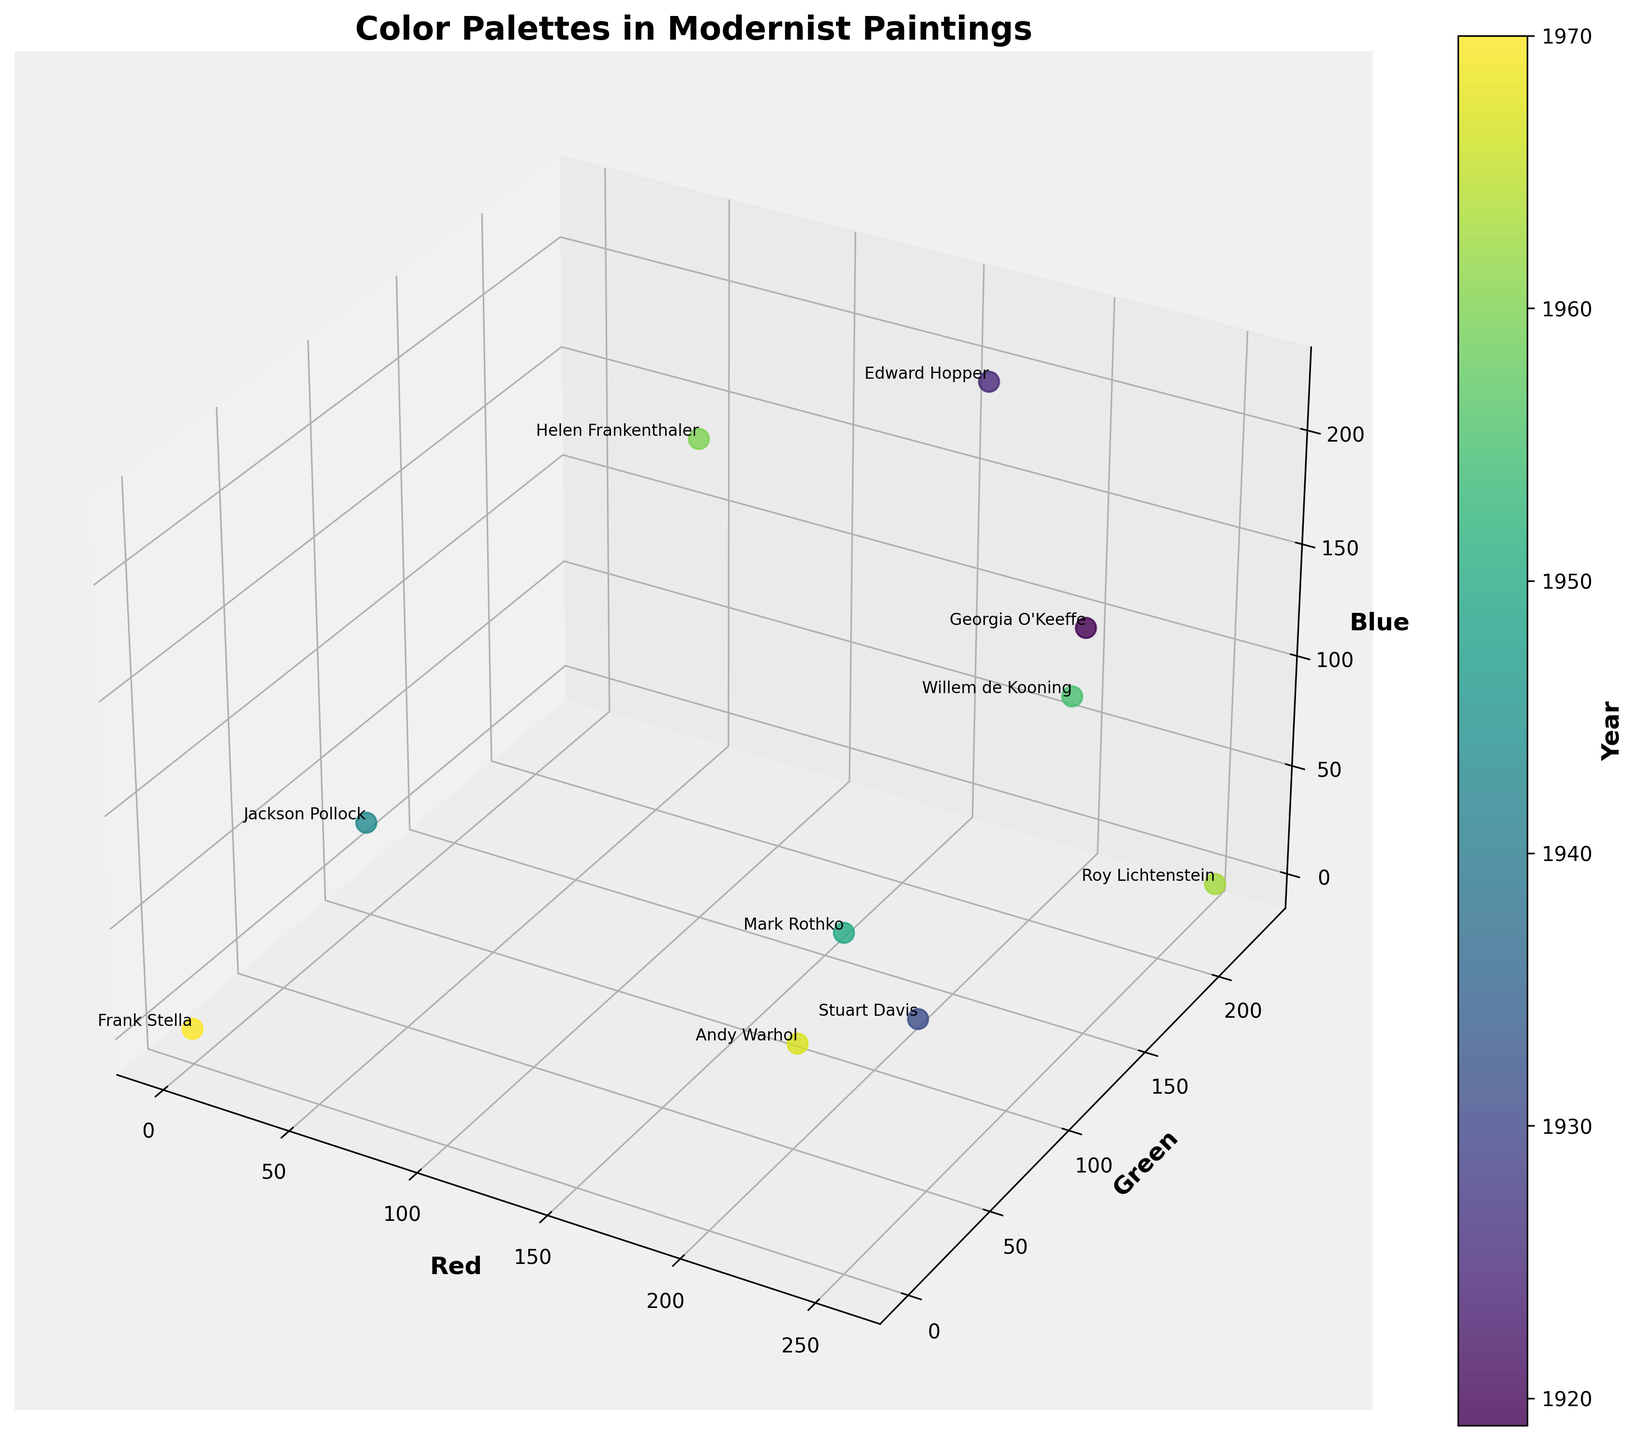What's the title of the plot? The title is typically indicated at the top of the plot in a larger or bold font. In this case, the title is "Color Palettes in Modernist Paintings."
Answer: Color Palettes in Modernist Paintings Which axis represents the red color component? The axes are labeled with the components they represent. The x-axis is labeled 'Red,' indicating it represents the red color component.
Answer: x-axis What is the color palette for Edward Hopper's painting? Edward Hopper's data point is located at (180, 200, 220) in the 3D space, representing the red, green, and blue components respectively. This indicates the color palette for his painting.
Answer: (180, 200, 220) Between the years 1919 and 1970, which artist used the highest amount of blue in their palette? Identify the data points for each artist between 1919 and 1970 and compare their blue values (z-axis). Andy Warhol, in 1967, has the highest blue value of 220.
Answer: Andy Warhol How many data points are there in the plot? Each artist represents one data point. The total number of artists listed is ten, corresponding to ten data points in the plot.
Answer: 10 Which artistic movement shows the highest variation in color within its category? By visually inspecting the spread of data points labeled with the same movement, it becomes evident that Abstract Expressionism (with varying red, green, and blue values) shows a significant spread.
Answer: Abstract Expressionism What's the average green value for artists in the Color Field Painting movement? Identify the green values for artists in Color Field Painting (Mark Rothko: 80, Helen Frankenthaler: 150), then calculate the average. (80 + 150) / 2 = 115.
Answer: 115 Compare the color palette of Stuart Davis with that of Roy Lichtenstein. What differences do you observe in their red, green, and blue values? Stuart Davis's values are (240, 60, 50) and Roy Lichtenstein's values are (255, 230, 0). Roy has higher red and green values but a lower blue value compared to Stuart.
Answer: Roy has higher red and green, lower blue Which artist's data point is closest to the origin (0, 0, 0)? The closest point to the origin can be found by identifying the data point with the smallest Euclidean distance to (0, 0, 0). Frank Stella, with values (0, 0, 0), is at the origin.
Answer: Frank Stella 